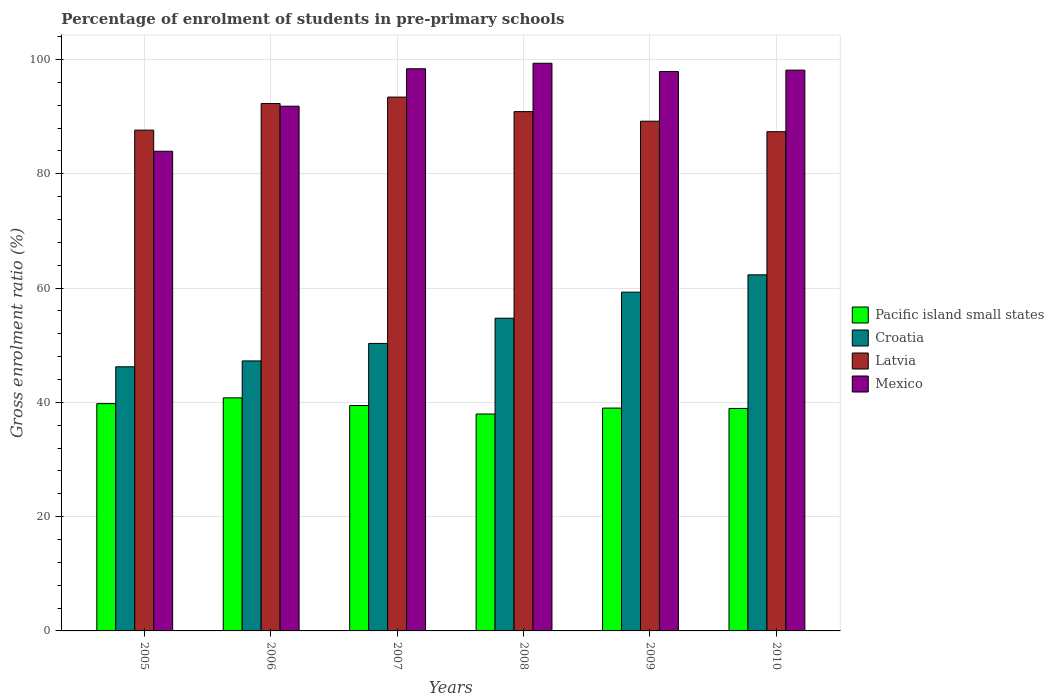How many different coloured bars are there?
Make the answer very short. 4. How many groups of bars are there?
Provide a short and direct response. 6. Are the number of bars per tick equal to the number of legend labels?
Provide a succinct answer. Yes. Are the number of bars on each tick of the X-axis equal?
Keep it short and to the point. Yes. In how many cases, is the number of bars for a given year not equal to the number of legend labels?
Offer a very short reply. 0. What is the percentage of students enrolled in pre-primary schools in Croatia in 2006?
Your answer should be very brief. 47.25. Across all years, what is the maximum percentage of students enrolled in pre-primary schools in Pacific island small states?
Make the answer very short. 40.78. Across all years, what is the minimum percentage of students enrolled in pre-primary schools in Mexico?
Offer a terse response. 83.94. What is the total percentage of students enrolled in pre-primary schools in Mexico in the graph?
Keep it short and to the point. 569.48. What is the difference between the percentage of students enrolled in pre-primary schools in Pacific island small states in 2005 and that in 2008?
Offer a terse response. 1.82. What is the difference between the percentage of students enrolled in pre-primary schools in Croatia in 2010 and the percentage of students enrolled in pre-primary schools in Latvia in 2009?
Provide a short and direct response. -26.88. What is the average percentage of students enrolled in pre-primary schools in Croatia per year?
Offer a terse response. 53.35. In the year 2009, what is the difference between the percentage of students enrolled in pre-primary schools in Croatia and percentage of students enrolled in pre-primary schools in Pacific island small states?
Make the answer very short. 20.29. What is the ratio of the percentage of students enrolled in pre-primary schools in Pacific island small states in 2009 to that in 2010?
Your answer should be compact. 1. Is the difference between the percentage of students enrolled in pre-primary schools in Croatia in 2005 and 2010 greater than the difference between the percentage of students enrolled in pre-primary schools in Pacific island small states in 2005 and 2010?
Offer a terse response. No. What is the difference between the highest and the second highest percentage of students enrolled in pre-primary schools in Croatia?
Keep it short and to the point. 3.03. What is the difference between the highest and the lowest percentage of students enrolled in pre-primary schools in Pacific island small states?
Make the answer very short. 2.83. Is it the case that in every year, the sum of the percentage of students enrolled in pre-primary schools in Pacific island small states and percentage of students enrolled in pre-primary schools in Latvia is greater than the sum of percentage of students enrolled in pre-primary schools in Mexico and percentage of students enrolled in pre-primary schools in Croatia?
Keep it short and to the point. Yes. What does the 4th bar from the left in 2006 represents?
Your answer should be very brief. Mexico. Is it the case that in every year, the sum of the percentage of students enrolled in pre-primary schools in Latvia and percentage of students enrolled in pre-primary schools in Pacific island small states is greater than the percentage of students enrolled in pre-primary schools in Croatia?
Your answer should be compact. Yes. How many bars are there?
Keep it short and to the point. 24. Are all the bars in the graph horizontal?
Make the answer very short. No. Does the graph contain any zero values?
Your answer should be very brief. No. Where does the legend appear in the graph?
Provide a succinct answer. Center right. What is the title of the graph?
Provide a succinct answer. Percentage of enrolment of students in pre-primary schools. What is the label or title of the Y-axis?
Provide a short and direct response. Gross enrolment ratio (%). What is the Gross enrolment ratio (%) in Pacific island small states in 2005?
Your answer should be very brief. 39.78. What is the Gross enrolment ratio (%) of Croatia in 2005?
Your response must be concise. 46.22. What is the Gross enrolment ratio (%) of Latvia in 2005?
Your answer should be compact. 87.63. What is the Gross enrolment ratio (%) of Mexico in 2005?
Your answer should be compact. 83.94. What is the Gross enrolment ratio (%) of Pacific island small states in 2006?
Your response must be concise. 40.78. What is the Gross enrolment ratio (%) in Croatia in 2006?
Provide a succinct answer. 47.25. What is the Gross enrolment ratio (%) in Latvia in 2006?
Ensure brevity in your answer.  92.29. What is the Gross enrolment ratio (%) of Mexico in 2006?
Provide a succinct answer. 91.82. What is the Gross enrolment ratio (%) of Pacific island small states in 2007?
Ensure brevity in your answer.  39.44. What is the Gross enrolment ratio (%) of Croatia in 2007?
Offer a terse response. 50.31. What is the Gross enrolment ratio (%) of Latvia in 2007?
Ensure brevity in your answer.  93.41. What is the Gross enrolment ratio (%) of Mexico in 2007?
Make the answer very short. 98.37. What is the Gross enrolment ratio (%) of Pacific island small states in 2008?
Provide a short and direct response. 37.96. What is the Gross enrolment ratio (%) in Croatia in 2008?
Provide a succinct answer. 54.72. What is the Gross enrolment ratio (%) in Latvia in 2008?
Your answer should be very brief. 90.87. What is the Gross enrolment ratio (%) of Mexico in 2008?
Provide a succinct answer. 99.33. What is the Gross enrolment ratio (%) in Pacific island small states in 2009?
Give a very brief answer. 38.99. What is the Gross enrolment ratio (%) of Croatia in 2009?
Offer a very short reply. 59.28. What is the Gross enrolment ratio (%) of Latvia in 2009?
Keep it short and to the point. 89.2. What is the Gross enrolment ratio (%) in Mexico in 2009?
Ensure brevity in your answer.  97.89. What is the Gross enrolment ratio (%) of Pacific island small states in 2010?
Provide a short and direct response. 38.93. What is the Gross enrolment ratio (%) of Croatia in 2010?
Offer a very short reply. 62.31. What is the Gross enrolment ratio (%) in Latvia in 2010?
Keep it short and to the point. 87.36. What is the Gross enrolment ratio (%) of Mexico in 2010?
Your response must be concise. 98.13. Across all years, what is the maximum Gross enrolment ratio (%) of Pacific island small states?
Offer a terse response. 40.78. Across all years, what is the maximum Gross enrolment ratio (%) in Croatia?
Provide a short and direct response. 62.31. Across all years, what is the maximum Gross enrolment ratio (%) of Latvia?
Offer a terse response. 93.41. Across all years, what is the maximum Gross enrolment ratio (%) of Mexico?
Your answer should be compact. 99.33. Across all years, what is the minimum Gross enrolment ratio (%) of Pacific island small states?
Ensure brevity in your answer.  37.96. Across all years, what is the minimum Gross enrolment ratio (%) of Croatia?
Make the answer very short. 46.22. Across all years, what is the minimum Gross enrolment ratio (%) in Latvia?
Make the answer very short. 87.36. Across all years, what is the minimum Gross enrolment ratio (%) in Mexico?
Keep it short and to the point. 83.94. What is the total Gross enrolment ratio (%) of Pacific island small states in the graph?
Ensure brevity in your answer.  235.88. What is the total Gross enrolment ratio (%) in Croatia in the graph?
Make the answer very short. 320.09. What is the total Gross enrolment ratio (%) in Latvia in the graph?
Make the answer very short. 540.76. What is the total Gross enrolment ratio (%) of Mexico in the graph?
Give a very brief answer. 569.48. What is the difference between the Gross enrolment ratio (%) in Pacific island small states in 2005 and that in 2006?
Offer a terse response. -1.01. What is the difference between the Gross enrolment ratio (%) in Croatia in 2005 and that in 2006?
Offer a very short reply. -1.03. What is the difference between the Gross enrolment ratio (%) in Latvia in 2005 and that in 2006?
Provide a short and direct response. -4.65. What is the difference between the Gross enrolment ratio (%) of Mexico in 2005 and that in 2006?
Make the answer very short. -7.88. What is the difference between the Gross enrolment ratio (%) of Pacific island small states in 2005 and that in 2007?
Make the answer very short. 0.33. What is the difference between the Gross enrolment ratio (%) of Croatia in 2005 and that in 2007?
Offer a very short reply. -4.09. What is the difference between the Gross enrolment ratio (%) of Latvia in 2005 and that in 2007?
Your answer should be very brief. -5.78. What is the difference between the Gross enrolment ratio (%) of Mexico in 2005 and that in 2007?
Provide a succinct answer. -14.43. What is the difference between the Gross enrolment ratio (%) in Pacific island small states in 2005 and that in 2008?
Offer a very short reply. 1.82. What is the difference between the Gross enrolment ratio (%) in Croatia in 2005 and that in 2008?
Your answer should be compact. -8.5. What is the difference between the Gross enrolment ratio (%) of Latvia in 2005 and that in 2008?
Make the answer very short. -3.24. What is the difference between the Gross enrolment ratio (%) of Mexico in 2005 and that in 2008?
Offer a very short reply. -15.4. What is the difference between the Gross enrolment ratio (%) of Pacific island small states in 2005 and that in 2009?
Your response must be concise. 0.78. What is the difference between the Gross enrolment ratio (%) of Croatia in 2005 and that in 2009?
Your answer should be compact. -13.06. What is the difference between the Gross enrolment ratio (%) of Latvia in 2005 and that in 2009?
Offer a terse response. -1.56. What is the difference between the Gross enrolment ratio (%) in Mexico in 2005 and that in 2009?
Provide a short and direct response. -13.95. What is the difference between the Gross enrolment ratio (%) of Pacific island small states in 2005 and that in 2010?
Make the answer very short. 0.84. What is the difference between the Gross enrolment ratio (%) in Croatia in 2005 and that in 2010?
Keep it short and to the point. -16.09. What is the difference between the Gross enrolment ratio (%) in Latvia in 2005 and that in 2010?
Your answer should be compact. 0.27. What is the difference between the Gross enrolment ratio (%) in Mexico in 2005 and that in 2010?
Provide a succinct answer. -14.19. What is the difference between the Gross enrolment ratio (%) in Pacific island small states in 2006 and that in 2007?
Keep it short and to the point. 1.34. What is the difference between the Gross enrolment ratio (%) in Croatia in 2006 and that in 2007?
Give a very brief answer. -3.06. What is the difference between the Gross enrolment ratio (%) in Latvia in 2006 and that in 2007?
Ensure brevity in your answer.  -1.13. What is the difference between the Gross enrolment ratio (%) in Mexico in 2006 and that in 2007?
Your response must be concise. -6.55. What is the difference between the Gross enrolment ratio (%) in Pacific island small states in 2006 and that in 2008?
Your answer should be very brief. 2.83. What is the difference between the Gross enrolment ratio (%) in Croatia in 2006 and that in 2008?
Provide a short and direct response. -7.47. What is the difference between the Gross enrolment ratio (%) in Latvia in 2006 and that in 2008?
Give a very brief answer. 1.41. What is the difference between the Gross enrolment ratio (%) in Mexico in 2006 and that in 2008?
Your answer should be compact. -7.51. What is the difference between the Gross enrolment ratio (%) in Pacific island small states in 2006 and that in 2009?
Provide a short and direct response. 1.79. What is the difference between the Gross enrolment ratio (%) of Croatia in 2006 and that in 2009?
Your answer should be very brief. -12.03. What is the difference between the Gross enrolment ratio (%) in Latvia in 2006 and that in 2009?
Keep it short and to the point. 3.09. What is the difference between the Gross enrolment ratio (%) in Mexico in 2006 and that in 2009?
Keep it short and to the point. -6.07. What is the difference between the Gross enrolment ratio (%) of Pacific island small states in 2006 and that in 2010?
Provide a succinct answer. 1.85. What is the difference between the Gross enrolment ratio (%) in Croatia in 2006 and that in 2010?
Ensure brevity in your answer.  -15.07. What is the difference between the Gross enrolment ratio (%) in Latvia in 2006 and that in 2010?
Ensure brevity in your answer.  4.93. What is the difference between the Gross enrolment ratio (%) of Mexico in 2006 and that in 2010?
Make the answer very short. -6.31. What is the difference between the Gross enrolment ratio (%) in Pacific island small states in 2007 and that in 2008?
Keep it short and to the point. 1.48. What is the difference between the Gross enrolment ratio (%) of Croatia in 2007 and that in 2008?
Make the answer very short. -4.41. What is the difference between the Gross enrolment ratio (%) of Latvia in 2007 and that in 2008?
Make the answer very short. 2.54. What is the difference between the Gross enrolment ratio (%) in Mexico in 2007 and that in 2008?
Offer a very short reply. -0.96. What is the difference between the Gross enrolment ratio (%) in Pacific island small states in 2007 and that in 2009?
Make the answer very short. 0.45. What is the difference between the Gross enrolment ratio (%) in Croatia in 2007 and that in 2009?
Provide a short and direct response. -8.97. What is the difference between the Gross enrolment ratio (%) of Latvia in 2007 and that in 2009?
Make the answer very short. 4.21. What is the difference between the Gross enrolment ratio (%) in Mexico in 2007 and that in 2009?
Offer a terse response. 0.48. What is the difference between the Gross enrolment ratio (%) in Pacific island small states in 2007 and that in 2010?
Your answer should be compact. 0.51. What is the difference between the Gross enrolment ratio (%) in Croatia in 2007 and that in 2010?
Ensure brevity in your answer.  -12. What is the difference between the Gross enrolment ratio (%) in Latvia in 2007 and that in 2010?
Your answer should be compact. 6.05. What is the difference between the Gross enrolment ratio (%) in Mexico in 2007 and that in 2010?
Offer a terse response. 0.24. What is the difference between the Gross enrolment ratio (%) of Pacific island small states in 2008 and that in 2009?
Make the answer very short. -1.04. What is the difference between the Gross enrolment ratio (%) in Croatia in 2008 and that in 2009?
Keep it short and to the point. -4.56. What is the difference between the Gross enrolment ratio (%) in Latvia in 2008 and that in 2009?
Provide a short and direct response. 1.67. What is the difference between the Gross enrolment ratio (%) in Mexico in 2008 and that in 2009?
Keep it short and to the point. 1.45. What is the difference between the Gross enrolment ratio (%) of Pacific island small states in 2008 and that in 2010?
Keep it short and to the point. -0.98. What is the difference between the Gross enrolment ratio (%) of Croatia in 2008 and that in 2010?
Give a very brief answer. -7.59. What is the difference between the Gross enrolment ratio (%) of Latvia in 2008 and that in 2010?
Offer a terse response. 3.51. What is the difference between the Gross enrolment ratio (%) of Mexico in 2008 and that in 2010?
Provide a succinct answer. 1.2. What is the difference between the Gross enrolment ratio (%) of Pacific island small states in 2009 and that in 2010?
Ensure brevity in your answer.  0.06. What is the difference between the Gross enrolment ratio (%) in Croatia in 2009 and that in 2010?
Provide a succinct answer. -3.03. What is the difference between the Gross enrolment ratio (%) of Latvia in 2009 and that in 2010?
Ensure brevity in your answer.  1.84. What is the difference between the Gross enrolment ratio (%) of Mexico in 2009 and that in 2010?
Provide a succinct answer. -0.24. What is the difference between the Gross enrolment ratio (%) of Pacific island small states in 2005 and the Gross enrolment ratio (%) of Croatia in 2006?
Your answer should be very brief. -7.47. What is the difference between the Gross enrolment ratio (%) of Pacific island small states in 2005 and the Gross enrolment ratio (%) of Latvia in 2006?
Give a very brief answer. -52.51. What is the difference between the Gross enrolment ratio (%) in Pacific island small states in 2005 and the Gross enrolment ratio (%) in Mexico in 2006?
Provide a succinct answer. -52.04. What is the difference between the Gross enrolment ratio (%) of Croatia in 2005 and the Gross enrolment ratio (%) of Latvia in 2006?
Give a very brief answer. -46.06. What is the difference between the Gross enrolment ratio (%) in Croatia in 2005 and the Gross enrolment ratio (%) in Mexico in 2006?
Offer a very short reply. -45.6. What is the difference between the Gross enrolment ratio (%) of Latvia in 2005 and the Gross enrolment ratio (%) of Mexico in 2006?
Your answer should be very brief. -4.19. What is the difference between the Gross enrolment ratio (%) of Pacific island small states in 2005 and the Gross enrolment ratio (%) of Croatia in 2007?
Your answer should be compact. -10.53. What is the difference between the Gross enrolment ratio (%) of Pacific island small states in 2005 and the Gross enrolment ratio (%) of Latvia in 2007?
Make the answer very short. -53.64. What is the difference between the Gross enrolment ratio (%) of Pacific island small states in 2005 and the Gross enrolment ratio (%) of Mexico in 2007?
Give a very brief answer. -58.6. What is the difference between the Gross enrolment ratio (%) of Croatia in 2005 and the Gross enrolment ratio (%) of Latvia in 2007?
Give a very brief answer. -47.19. What is the difference between the Gross enrolment ratio (%) of Croatia in 2005 and the Gross enrolment ratio (%) of Mexico in 2007?
Provide a succinct answer. -52.15. What is the difference between the Gross enrolment ratio (%) of Latvia in 2005 and the Gross enrolment ratio (%) of Mexico in 2007?
Keep it short and to the point. -10.74. What is the difference between the Gross enrolment ratio (%) in Pacific island small states in 2005 and the Gross enrolment ratio (%) in Croatia in 2008?
Offer a terse response. -14.95. What is the difference between the Gross enrolment ratio (%) of Pacific island small states in 2005 and the Gross enrolment ratio (%) of Latvia in 2008?
Your answer should be compact. -51.1. What is the difference between the Gross enrolment ratio (%) in Pacific island small states in 2005 and the Gross enrolment ratio (%) in Mexico in 2008?
Provide a succinct answer. -59.56. What is the difference between the Gross enrolment ratio (%) of Croatia in 2005 and the Gross enrolment ratio (%) of Latvia in 2008?
Provide a succinct answer. -44.65. What is the difference between the Gross enrolment ratio (%) of Croatia in 2005 and the Gross enrolment ratio (%) of Mexico in 2008?
Your answer should be very brief. -53.11. What is the difference between the Gross enrolment ratio (%) in Latvia in 2005 and the Gross enrolment ratio (%) in Mexico in 2008?
Your answer should be very brief. -11.7. What is the difference between the Gross enrolment ratio (%) in Pacific island small states in 2005 and the Gross enrolment ratio (%) in Croatia in 2009?
Ensure brevity in your answer.  -19.5. What is the difference between the Gross enrolment ratio (%) of Pacific island small states in 2005 and the Gross enrolment ratio (%) of Latvia in 2009?
Ensure brevity in your answer.  -49.42. What is the difference between the Gross enrolment ratio (%) in Pacific island small states in 2005 and the Gross enrolment ratio (%) in Mexico in 2009?
Ensure brevity in your answer.  -58.11. What is the difference between the Gross enrolment ratio (%) of Croatia in 2005 and the Gross enrolment ratio (%) of Latvia in 2009?
Offer a very short reply. -42.98. What is the difference between the Gross enrolment ratio (%) of Croatia in 2005 and the Gross enrolment ratio (%) of Mexico in 2009?
Your answer should be very brief. -51.67. What is the difference between the Gross enrolment ratio (%) in Latvia in 2005 and the Gross enrolment ratio (%) in Mexico in 2009?
Provide a succinct answer. -10.25. What is the difference between the Gross enrolment ratio (%) of Pacific island small states in 2005 and the Gross enrolment ratio (%) of Croatia in 2010?
Your answer should be compact. -22.54. What is the difference between the Gross enrolment ratio (%) in Pacific island small states in 2005 and the Gross enrolment ratio (%) in Latvia in 2010?
Provide a short and direct response. -47.58. What is the difference between the Gross enrolment ratio (%) of Pacific island small states in 2005 and the Gross enrolment ratio (%) of Mexico in 2010?
Your response must be concise. -58.36. What is the difference between the Gross enrolment ratio (%) in Croatia in 2005 and the Gross enrolment ratio (%) in Latvia in 2010?
Your answer should be very brief. -41.14. What is the difference between the Gross enrolment ratio (%) in Croatia in 2005 and the Gross enrolment ratio (%) in Mexico in 2010?
Your answer should be very brief. -51.91. What is the difference between the Gross enrolment ratio (%) of Latvia in 2005 and the Gross enrolment ratio (%) of Mexico in 2010?
Give a very brief answer. -10.5. What is the difference between the Gross enrolment ratio (%) of Pacific island small states in 2006 and the Gross enrolment ratio (%) of Croatia in 2007?
Ensure brevity in your answer.  -9.53. What is the difference between the Gross enrolment ratio (%) in Pacific island small states in 2006 and the Gross enrolment ratio (%) in Latvia in 2007?
Provide a short and direct response. -52.63. What is the difference between the Gross enrolment ratio (%) of Pacific island small states in 2006 and the Gross enrolment ratio (%) of Mexico in 2007?
Your answer should be compact. -57.59. What is the difference between the Gross enrolment ratio (%) in Croatia in 2006 and the Gross enrolment ratio (%) in Latvia in 2007?
Keep it short and to the point. -46.16. What is the difference between the Gross enrolment ratio (%) in Croatia in 2006 and the Gross enrolment ratio (%) in Mexico in 2007?
Offer a terse response. -51.12. What is the difference between the Gross enrolment ratio (%) in Latvia in 2006 and the Gross enrolment ratio (%) in Mexico in 2007?
Keep it short and to the point. -6.09. What is the difference between the Gross enrolment ratio (%) of Pacific island small states in 2006 and the Gross enrolment ratio (%) of Croatia in 2008?
Your answer should be compact. -13.94. What is the difference between the Gross enrolment ratio (%) of Pacific island small states in 2006 and the Gross enrolment ratio (%) of Latvia in 2008?
Your answer should be compact. -50.09. What is the difference between the Gross enrolment ratio (%) of Pacific island small states in 2006 and the Gross enrolment ratio (%) of Mexico in 2008?
Ensure brevity in your answer.  -58.55. What is the difference between the Gross enrolment ratio (%) of Croatia in 2006 and the Gross enrolment ratio (%) of Latvia in 2008?
Keep it short and to the point. -43.62. What is the difference between the Gross enrolment ratio (%) in Croatia in 2006 and the Gross enrolment ratio (%) in Mexico in 2008?
Your answer should be compact. -52.09. What is the difference between the Gross enrolment ratio (%) in Latvia in 2006 and the Gross enrolment ratio (%) in Mexico in 2008?
Offer a very short reply. -7.05. What is the difference between the Gross enrolment ratio (%) of Pacific island small states in 2006 and the Gross enrolment ratio (%) of Croatia in 2009?
Your answer should be very brief. -18.5. What is the difference between the Gross enrolment ratio (%) of Pacific island small states in 2006 and the Gross enrolment ratio (%) of Latvia in 2009?
Provide a short and direct response. -48.41. What is the difference between the Gross enrolment ratio (%) in Pacific island small states in 2006 and the Gross enrolment ratio (%) in Mexico in 2009?
Your answer should be compact. -57.11. What is the difference between the Gross enrolment ratio (%) of Croatia in 2006 and the Gross enrolment ratio (%) of Latvia in 2009?
Provide a succinct answer. -41.95. What is the difference between the Gross enrolment ratio (%) in Croatia in 2006 and the Gross enrolment ratio (%) in Mexico in 2009?
Your answer should be compact. -50.64. What is the difference between the Gross enrolment ratio (%) in Latvia in 2006 and the Gross enrolment ratio (%) in Mexico in 2009?
Offer a terse response. -5.6. What is the difference between the Gross enrolment ratio (%) in Pacific island small states in 2006 and the Gross enrolment ratio (%) in Croatia in 2010?
Provide a succinct answer. -21.53. What is the difference between the Gross enrolment ratio (%) in Pacific island small states in 2006 and the Gross enrolment ratio (%) in Latvia in 2010?
Provide a succinct answer. -46.58. What is the difference between the Gross enrolment ratio (%) of Pacific island small states in 2006 and the Gross enrolment ratio (%) of Mexico in 2010?
Provide a short and direct response. -57.35. What is the difference between the Gross enrolment ratio (%) in Croatia in 2006 and the Gross enrolment ratio (%) in Latvia in 2010?
Give a very brief answer. -40.11. What is the difference between the Gross enrolment ratio (%) of Croatia in 2006 and the Gross enrolment ratio (%) of Mexico in 2010?
Ensure brevity in your answer.  -50.88. What is the difference between the Gross enrolment ratio (%) in Latvia in 2006 and the Gross enrolment ratio (%) in Mexico in 2010?
Provide a short and direct response. -5.85. What is the difference between the Gross enrolment ratio (%) in Pacific island small states in 2007 and the Gross enrolment ratio (%) in Croatia in 2008?
Offer a terse response. -15.28. What is the difference between the Gross enrolment ratio (%) in Pacific island small states in 2007 and the Gross enrolment ratio (%) in Latvia in 2008?
Provide a short and direct response. -51.43. What is the difference between the Gross enrolment ratio (%) of Pacific island small states in 2007 and the Gross enrolment ratio (%) of Mexico in 2008?
Provide a succinct answer. -59.89. What is the difference between the Gross enrolment ratio (%) in Croatia in 2007 and the Gross enrolment ratio (%) in Latvia in 2008?
Provide a succinct answer. -40.56. What is the difference between the Gross enrolment ratio (%) of Croatia in 2007 and the Gross enrolment ratio (%) of Mexico in 2008?
Provide a short and direct response. -49.03. What is the difference between the Gross enrolment ratio (%) of Latvia in 2007 and the Gross enrolment ratio (%) of Mexico in 2008?
Ensure brevity in your answer.  -5.92. What is the difference between the Gross enrolment ratio (%) of Pacific island small states in 2007 and the Gross enrolment ratio (%) of Croatia in 2009?
Your response must be concise. -19.84. What is the difference between the Gross enrolment ratio (%) in Pacific island small states in 2007 and the Gross enrolment ratio (%) in Latvia in 2009?
Offer a very short reply. -49.76. What is the difference between the Gross enrolment ratio (%) in Pacific island small states in 2007 and the Gross enrolment ratio (%) in Mexico in 2009?
Offer a terse response. -58.45. What is the difference between the Gross enrolment ratio (%) of Croatia in 2007 and the Gross enrolment ratio (%) of Latvia in 2009?
Offer a very short reply. -38.89. What is the difference between the Gross enrolment ratio (%) in Croatia in 2007 and the Gross enrolment ratio (%) in Mexico in 2009?
Your response must be concise. -47.58. What is the difference between the Gross enrolment ratio (%) of Latvia in 2007 and the Gross enrolment ratio (%) of Mexico in 2009?
Ensure brevity in your answer.  -4.48. What is the difference between the Gross enrolment ratio (%) of Pacific island small states in 2007 and the Gross enrolment ratio (%) of Croatia in 2010?
Offer a terse response. -22.87. What is the difference between the Gross enrolment ratio (%) in Pacific island small states in 2007 and the Gross enrolment ratio (%) in Latvia in 2010?
Your answer should be very brief. -47.92. What is the difference between the Gross enrolment ratio (%) of Pacific island small states in 2007 and the Gross enrolment ratio (%) of Mexico in 2010?
Your answer should be compact. -58.69. What is the difference between the Gross enrolment ratio (%) of Croatia in 2007 and the Gross enrolment ratio (%) of Latvia in 2010?
Keep it short and to the point. -37.05. What is the difference between the Gross enrolment ratio (%) in Croatia in 2007 and the Gross enrolment ratio (%) in Mexico in 2010?
Your answer should be compact. -47.82. What is the difference between the Gross enrolment ratio (%) of Latvia in 2007 and the Gross enrolment ratio (%) of Mexico in 2010?
Your response must be concise. -4.72. What is the difference between the Gross enrolment ratio (%) of Pacific island small states in 2008 and the Gross enrolment ratio (%) of Croatia in 2009?
Your response must be concise. -21.32. What is the difference between the Gross enrolment ratio (%) in Pacific island small states in 2008 and the Gross enrolment ratio (%) in Latvia in 2009?
Your response must be concise. -51.24. What is the difference between the Gross enrolment ratio (%) of Pacific island small states in 2008 and the Gross enrolment ratio (%) of Mexico in 2009?
Provide a succinct answer. -59.93. What is the difference between the Gross enrolment ratio (%) in Croatia in 2008 and the Gross enrolment ratio (%) in Latvia in 2009?
Ensure brevity in your answer.  -34.48. What is the difference between the Gross enrolment ratio (%) of Croatia in 2008 and the Gross enrolment ratio (%) of Mexico in 2009?
Ensure brevity in your answer.  -43.17. What is the difference between the Gross enrolment ratio (%) of Latvia in 2008 and the Gross enrolment ratio (%) of Mexico in 2009?
Provide a short and direct response. -7.02. What is the difference between the Gross enrolment ratio (%) in Pacific island small states in 2008 and the Gross enrolment ratio (%) in Croatia in 2010?
Offer a very short reply. -24.36. What is the difference between the Gross enrolment ratio (%) of Pacific island small states in 2008 and the Gross enrolment ratio (%) of Latvia in 2010?
Your response must be concise. -49.4. What is the difference between the Gross enrolment ratio (%) of Pacific island small states in 2008 and the Gross enrolment ratio (%) of Mexico in 2010?
Provide a short and direct response. -60.17. What is the difference between the Gross enrolment ratio (%) of Croatia in 2008 and the Gross enrolment ratio (%) of Latvia in 2010?
Your response must be concise. -32.64. What is the difference between the Gross enrolment ratio (%) in Croatia in 2008 and the Gross enrolment ratio (%) in Mexico in 2010?
Your answer should be very brief. -43.41. What is the difference between the Gross enrolment ratio (%) in Latvia in 2008 and the Gross enrolment ratio (%) in Mexico in 2010?
Ensure brevity in your answer.  -7.26. What is the difference between the Gross enrolment ratio (%) of Pacific island small states in 2009 and the Gross enrolment ratio (%) of Croatia in 2010?
Make the answer very short. -23.32. What is the difference between the Gross enrolment ratio (%) in Pacific island small states in 2009 and the Gross enrolment ratio (%) in Latvia in 2010?
Provide a succinct answer. -48.37. What is the difference between the Gross enrolment ratio (%) of Pacific island small states in 2009 and the Gross enrolment ratio (%) of Mexico in 2010?
Make the answer very short. -59.14. What is the difference between the Gross enrolment ratio (%) of Croatia in 2009 and the Gross enrolment ratio (%) of Latvia in 2010?
Offer a very short reply. -28.08. What is the difference between the Gross enrolment ratio (%) of Croatia in 2009 and the Gross enrolment ratio (%) of Mexico in 2010?
Your response must be concise. -38.85. What is the difference between the Gross enrolment ratio (%) in Latvia in 2009 and the Gross enrolment ratio (%) in Mexico in 2010?
Keep it short and to the point. -8.93. What is the average Gross enrolment ratio (%) in Pacific island small states per year?
Provide a short and direct response. 39.31. What is the average Gross enrolment ratio (%) of Croatia per year?
Your response must be concise. 53.35. What is the average Gross enrolment ratio (%) in Latvia per year?
Provide a short and direct response. 90.13. What is the average Gross enrolment ratio (%) of Mexico per year?
Your response must be concise. 94.91. In the year 2005, what is the difference between the Gross enrolment ratio (%) in Pacific island small states and Gross enrolment ratio (%) in Croatia?
Keep it short and to the point. -6.45. In the year 2005, what is the difference between the Gross enrolment ratio (%) in Pacific island small states and Gross enrolment ratio (%) in Latvia?
Keep it short and to the point. -47.86. In the year 2005, what is the difference between the Gross enrolment ratio (%) of Pacific island small states and Gross enrolment ratio (%) of Mexico?
Provide a short and direct response. -44.16. In the year 2005, what is the difference between the Gross enrolment ratio (%) in Croatia and Gross enrolment ratio (%) in Latvia?
Your answer should be compact. -41.41. In the year 2005, what is the difference between the Gross enrolment ratio (%) of Croatia and Gross enrolment ratio (%) of Mexico?
Offer a very short reply. -37.72. In the year 2005, what is the difference between the Gross enrolment ratio (%) in Latvia and Gross enrolment ratio (%) in Mexico?
Make the answer very short. 3.7. In the year 2006, what is the difference between the Gross enrolment ratio (%) of Pacific island small states and Gross enrolment ratio (%) of Croatia?
Your response must be concise. -6.47. In the year 2006, what is the difference between the Gross enrolment ratio (%) in Pacific island small states and Gross enrolment ratio (%) in Latvia?
Your response must be concise. -51.5. In the year 2006, what is the difference between the Gross enrolment ratio (%) of Pacific island small states and Gross enrolment ratio (%) of Mexico?
Keep it short and to the point. -51.04. In the year 2006, what is the difference between the Gross enrolment ratio (%) of Croatia and Gross enrolment ratio (%) of Latvia?
Offer a terse response. -45.04. In the year 2006, what is the difference between the Gross enrolment ratio (%) in Croatia and Gross enrolment ratio (%) in Mexico?
Give a very brief answer. -44.57. In the year 2006, what is the difference between the Gross enrolment ratio (%) in Latvia and Gross enrolment ratio (%) in Mexico?
Keep it short and to the point. 0.47. In the year 2007, what is the difference between the Gross enrolment ratio (%) in Pacific island small states and Gross enrolment ratio (%) in Croatia?
Your response must be concise. -10.87. In the year 2007, what is the difference between the Gross enrolment ratio (%) in Pacific island small states and Gross enrolment ratio (%) in Latvia?
Your answer should be compact. -53.97. In the year 2007, what is the difference between the Gross enrolment ratio (%) of Pacific island small states and Gross enrolment ratio (%) of Mexico?
Provide a succinct answer. -58.93. In the year 2007, what is the difference between the Gross enrolment ratio (%) of Croatia and Gross enrolment ratio (%) of Latvia?
Provide a short and direct response. -43.1. In the year 2007, what is the difference between the Gross enrolment ratio (%) in Croatia and Gross enrolment ratio (%) in Mexico?
Provide a succinct answer. -48.06. In the year 2007, what is the difference between the Gross enrolment ratio (%) in Latvia and Gross enrolment ratio (%) in Mexico?
Offer a terse response. -4.96. In the year 2008, what is the difference between the Gross enrolment ratio (%) of Pacific island small states and Gross enrolment ratio (%) of Croatia?
Offer a terse response. -16.76. In the year 2008, what is the difference between the Gross enrolment ratio (%) in Pacific island small states and Gross enrolment ratio (%) in Latvia?
Provide a succinct answer. -52.92. In the year 2008, what is the difference between the Gross enrolment ratio (%) of Pacific island small states and Gross enrolment ratio (%) of Mexico?
Give a very brief answer. -61.38. In the year 2008, what is the difference between the Gross enrolment ratio (%) in Croatia and Gross enrolment ratio (%) in Latvia?
Your answer should be compact. -36.15. In the year 2008, what is the difference between the Gross enrolment ratio (%) in Croatia and Gross enrolment ratio (%) in Mexico?
Ensure brevity in your answer.  -44.61. In the year 2008, what is the difference between the Gross enrolment ratio (%) in Latvia and Gross enrolment ratio (%) in Mexico?
Provide a short and direct response. -8.46. In the year 2009, what is the difference between the Gross enrolment ratio (%) in Pacific island small states and Gross enrolment ratio (%) in Croatia?
Make the answer very short. -20.29. In the year 2009, what is the difference between the Gross enrolment ratio (%) in Pacific island small states and Gross enrolment ratio (%) in Latvia?
Provide a succinct answer. -50.2. In the year 2009, what is the difference between the Gross enrolment ratio (%) in Pacific island small states and Gross enrolment ratio (%) in Mexico?
Make the answer very short. -58.9. In the year 2009, what is the difference between the Gross enrolment ratio (%) in Croatia and Gross enrolment ratio (%) in Latvia?
Keep it short and to the point. -29.92. In the year 2009, what is the difference between the Gross enrolment ratio (%) in Croatia and Gross enrolment ratio (%) in Mexico?
Give a very brief answer. -38.61. In the year 2009, what is the difference between the Gross enrolment ratio (%) of Latvia and Gross enrolment ratio (%) of Mexico?
Your response must be concise. -8.69. In the year 2010, what is the difference between the Gross enrolment ratio (%) in Pacific island small states and Gross enrolment ratio (%) in Croatia?
Your answer should be compact. -23.38. In the year 2010, what is the difference between the Gross enrolment ratio (%) of Pacific island small states and Gross enrolment ratio (%) of Latvia?
Provide a short and direct response. -48.43. In the year 2010, what is the difference between the Gross enrolment ratio (%) of Pacific island small states and Gross enrolment ratio (%) of Mexico?
Make the answer very short. -59.2. In the year 2010, what is the difference between the Gross enrolment ratio (%) in Croatia and Gross enrolment ratio (%) in Latvia?
Your answer should be compact. -25.05. In the year 2010, what is the difference between the Gross enrolment ratio (%) in Croatia and Gross enrolment ratio (%) in Mexico?
Give a very brief answer. -35.82. In the year 2010, what is the difference between the Gross enrolment ratio (%) of Latvia and Gross enrolment ratio (%) of Mexico?
Offer a terse response. -10.77. What is the ratio of the Gross enrolment ratio (%) of Pacific island small states in 2005 to that in 2006?
Give a very brief answer. 0.98. What is the ratio of the Gross enrolment ratio (%) of Croatia in 2005 to that in 2006?
Offer a terse response. 0.98. What is the ratio of the Gross enrolment ratio (%) in Latvia in 2005 to that in 2006?
Offer a terse response. 0.95. What is the ratio of the Gross enrolment ratio (%) in Mexico in 2005 to that in 2006?
Give a very brief answer. 0.91. What is the ratio of the Gross enrolment ratio (%) in Pacific island small states in 2005 to that in 2007?
Keep it short and to the point. 1.01. What is the ratio of the Gross enrolment ratio (%) in Croatia in 2005 to that in 2007?
Ensure brevity in your answer.  0.92. What is the ratio of the Gross enrolment ratio (%) in Latvia in 2005 to that in 2007?
Your answer should be compact. 0.94. What is the ratio of the Gross enrolment ratio (%) of Mexico in 2005 to that in 2007?
Offer a very short reply. 0.85. What is the ratio of the Gross enrolment ratio (%) in Pacific island small states in 2005 to that in 2008?
Give a very brief answer. 1.05. What is the ratio of the Gross enrolment ratio (%) in Croatia in 2005 to that in 2008?
Offer a terse response. 0.84. What is the ratio of the Gross enrolment ratio (%) of Latvia in 2005 to that in 2008?
Keep it short and to the point. 0.96. What is the ratio of the Gross enrolment ratio (%) of Mexico in 2005 to that in 2008?
Your response must be concise. 0.84. What is the ratio of the Gross enrolment ratio (%) in Pacific island small states in 2005 to that in 2009?
Keep it short and to the point. 1.02. What is the ratio of the Gross enrolment ratio (%) of Croatia in 2005 to that in 2009?
Offer a very short reply. 0.78. What is the ratio of the Gross enrolment ratio (%) in Latvia in 2005 to that in 2009?
Your answer should be very brief. 0.98. What is the ratio of the Gross enrolment ratio (%) of Mexico in 2005 to that in 2009?
Your answer should be very brief. 0.86. What is the ratio of the Gross enrolment ratio (%) in Pacific island small states in 2005 to that in 2010?
Offer a terse response. 1.02. What is the ratio of the Gross enrolment ratio (%) in Croatia in 2005 to that in 2010?
Your response must be concise. 0.74. What is the ratio of the Gross enrolment ratio (%) in Mexico in 2005 to that in 2010?
Ensure brevity in your answer.  0.86. What is the ratio of the Gross enrolment ratio (%) of Pacific island small states in 2006 to that in 2007?
Offer a very short reply. 1.03. What is the ratio of the Gross enrolment ratio (%) of Croatia in 2006 to that in 2007?
Give a very brief answer. 0.94. What is the ratio of the Gross enrolment ratio (%) of Latvia in 2006 to that in 2007?
Offer a very short reply. 0.99. What is the ratio of the Gross enrolment ratio (%) in Mexico in 2006 to that in 2007?
Ensure brevity in your answer.  0.93. What is the ratio of the Gross enrolment ratio (%) of Pacific island small states in 2006 to that in 2008?
Offer a very short reply. 1.07. What is the ratio of the Gross enrolment ratio (%) of Croatia in 2006 to that in 2008?
Offer a terse response. 0.86. What is the ratio of the Gross enrolment ratio (%) of Latvia in 2006 to that in 2008?
Give a very brief answer. 1.02. What is the ratio of the Gross enrolment ratio (%) of Mexico in 2006 to that in 2008?
Keep it short and to the point. 0.92. What is the ratio of the Gross enrolment ratio (%) of Pacific island small states in 2006 to that in 2009?
Offer a terse response. 1.05. What is the ratio of the Gross enrolment ratio (%) of Croatia in 2006 to that in 2009?
Offer a very short reply. 0.8. What is the ratio of the Gross enrolment ratio (%) of Latvia in 2006 to that in 2009?
Provide a short and direct response. 1.03. What is the ratio of the Gross enrolment ratio (%) in Mexico in 2006 to that in 2009?
Make the answer very short. 0.94. What is the ratio of the Gross enrolment ratio (%) of Pacific island small states in 2006 to that in 2010?
Make the answer very short. 1.05. What is the ratio of the Gross enrolment ratio (%) of Croatia in 2006 to that in 2010?
Your answer should be compact. 0.76. What is the ratio of the Gross enrolment ratio (%) of Latvia in 2006 to that in 2010?
Provide a succinct answer. 1.06. What is the ratio of the Gross enrolment ratio (%) in Mexico in 2006 to that in 2010?
Provide a succinct answer. 0.94. What is the ratio of the Gross enrolment ratio (%) of Pacific island small states in 2007 to that in 2008?
Provide a short and direct response. 1.04. What is the ratio of the Gross enrolment ratio (%) of Croatia in 2007 to that in 2008?
Give a very brief answer. 0.92. What is the ratio of the Gross enrolment ratio (%) of Latvia in 2007 to that in 2008?
Your response must be concise. 1.03. What is the ratio of the Gross enrolment ratio (%) of Mexico in 2007 to that in 2008?
Offer a terse response. 0.99. What is the ratio of the Gross enrolment ratio (%) in Pacific island small states in 2007 to that in 2009?
Provide a succinct answer. 1.01. What is the ratio of the Gross enrolment ratio (%) of Croatia in 2007 to that in 2009?
Offer a very short reply. 0.85. What is the ratio of the Gross enrolment ratio (%) of Latvia in 2007 to that in 2009?
Keep it short and to the point. 1.05. What is the ratio of the Gross enrolment ratio (%) in Mexico in 2007 to that in 2009?
Provide a succinct answer. 1. What is the ratio of the Gross enrolment ratio (%) in Pacific island small states in 2007 to that in 2010?
Give a very brief answer. 1.01. What is the ratio of the Gross enrolment ratio (%) in Croatia in 2007 to that in 2010?
Offer a very short reply. 0.81. What is the ratio of the Gross enrolment ratio (%) of Latvia in 2007 to that in 2010?
Provide a succinct answer. 1.07. What is the ratio of the Gross enrolment ratio (%) of Pacific island small states in 2008 to that in 2009?
Offer a very short reply. 0.97. What is the ratio of the Gross enrolment ratio (%) of Croatia in 2008 to that in 2009?
Give a very brief answer. 0.92. What is the ratio of the Gross enrolment ratio (%) of Latvia in 2008 to that in 2009?
Provide a short and direct response. 1.02. What is the ratio of the Gross enrolment ratio (%) in Mexico in 2008 to that in 2009?
Your answer should be very brief. 1.01. What is the ratio of the Gross enrolment ratio (%) in Pacific island small states in 2008 to that in 2010?
Your answer should be very brief. 0.97. What is the ratio of the Gross enrolment ratio (%) in Croatia in 2008 to that in 2010?
Give a very brief answer. 0.88. What is the ratio of the Gross enrolment ratio (%) in Latvia in 2008 to that in 2010?
Provide a short and direct response. 1.04. What is the ratio of the Gross enrolment ratio (%) in Mexico in 2008 to that in 2010?
Your answer should be very brief. 1.01. What is the ratio of the Gross enrolment ratio (%) in Croatia in 2009 to that in 2010?
Provide a succinct answer. 0.95. What is the ratio of the Gross enrolment ratio (%) in Mexico in 2009 to that in 2010?
Give a very brief answer. 1. What is the difference between the highest and the second highest Gross enrolment ratio (%) of Croatia?
Provide a short and direct response. 3.03. What is the difference between the highest and the second highest Gross enrolment ratio (%) of Latvia?
Keep it short and to the point. 1.13. What is the difference between the highest and the second highest Gross enrolment ratio (%) in Mexico?
Your answer should be very brief. 0.96. What is the difference between the highest and the lowest Gross enrolment ratio (%) in Pacific island small states?
Ensure brevity in your answer.  2.83. What is the difference between the highest and the lowest Gross enrolment ratio (%) in Croatia?
Provide a succinct answer. 16.09. What is the difference between the highest and the lowest Gross enrolment ratio (%) in Latvia?
Your response must be concise. 6.05. What is the difference between the highest and the lowest Gross enrolment ratio (%) of Mexico?
Your answer should be very brief. 15.4. 